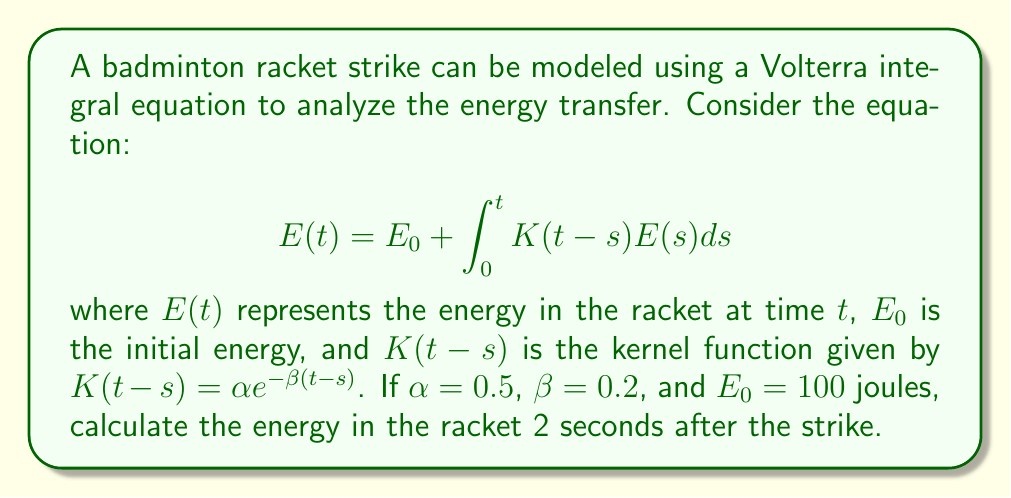What is the answer to this math problem? To solve this Volterra integral equation, we'll follow these steps:

1) First, we need to use the Laplace transform to convert the integral equation into an algebraic equation. Let $\mathcal{L}\{E(t)\} = \bar{E}(p)$. Taking the Laplace transform of both sides:

   $$\bar{E}(p) = \frac{E_0}{p} + \mathcal{L}\{K(t)\}\bar{E}(p)$$

2) The Laplace transform of the kernel $K(t) = \alpha e^{-\beta t}$ is:

   $$\mathcal{L}\{K(t)\} = \frac{\alpha}{p+\beta}$$

3) Substituting this into our equation:

   $$\bar{E}(p) = \frac{E_0}{p} + \frac{\alpha}{p+\beta}\bar{E}(p)$$

4) Solving for $\bar{E}(p)$:

   $$\bar{E}(p) = \frac{E_0}{p-\frac{\alpha}{p+\beta}}$$

5) This can be rewritten as:

   $$\bar{E}(p) = \frac{E_0(p+\beta)}{p(p+\beta)-\alpha}$$

6) The inverse Laplace transform of this expression gives us:

   $$E(t) = E_0\left(1 + \frac{\alpha}{\sqrt{\beta^2+4\alpha}-\beta}\left(e^{\frac{1}{2}(\sqrt{\beta^2+4\alpha}-\beta)t} - 1\right)\right)$$

7) Now we can substitute our values: $E_0 = 100$, $\alpha = 0.5$, $\beta = 0.2$, and $t = 2$:

   $$E(2) = 100\left(1 + \frac{0.5}{\sqrt{0.2^2+4(0.5)}-0.2}\left(e^{\frac{1}{2}(\sqrt{0.2^2+4(0.5)}-0.2)2} - 1\right)\right)$$

8) Calculating this:

   $$E(2) \approx 259.68$$ joules
Answer: 259.68 joules 